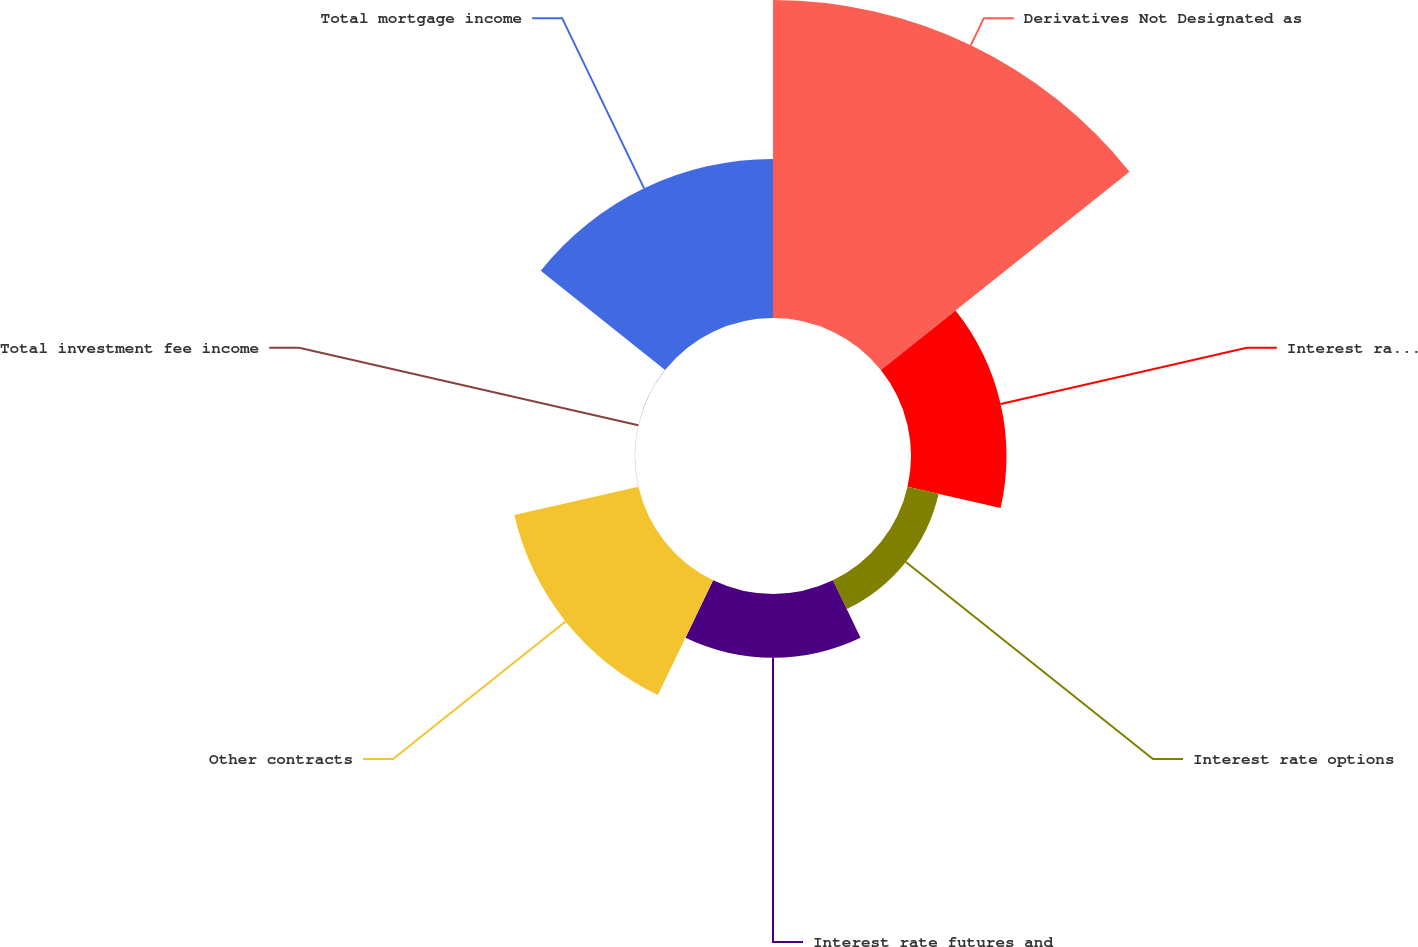Convert chart. <chart><loc_0><loc_0><loc_500><loc_500><pie_chart><fcel>Derivatives Not Designated as<fcel>Interest rate swaps<fcel>Interest rate options<fcel>Interest rate futures and<fcel>Other contracts<fcel>Total investment fee income<fcel>Total mortgage income<nl><fcel>39.96%<fcel>12.0%<fcel>4.01%<fcel>8.01%<fcel>16.0%<fcel>0.02%<fcel>19.99%<nl></chart> 